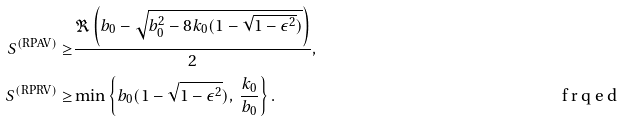Convert formula to latex. <formula><loc_0><loc_0><loc_500><loc_500>S ^ { ( \text {RPAV} ) } \geq & \frac { \Re \left ( b _ { 0 } - \sqrt { b _ { 0 } ^ { 2 } - 8 k _ { 0 } ( 1 - \sqrt { 1 - \epsilon ^ { 2 } } ) } \right ) } { 2 } , \\ S ^ { ( \text {RPRV} ) } \geq & \min \left \{ b _ { 0 } ( 1 - \sqrt { 1 - \epsilon ^ { 2 } } ) , \ \frac { k _ { 0 } } { b _ { 0 } } \right \} . \tag* { \ f r q e d }</formula> 